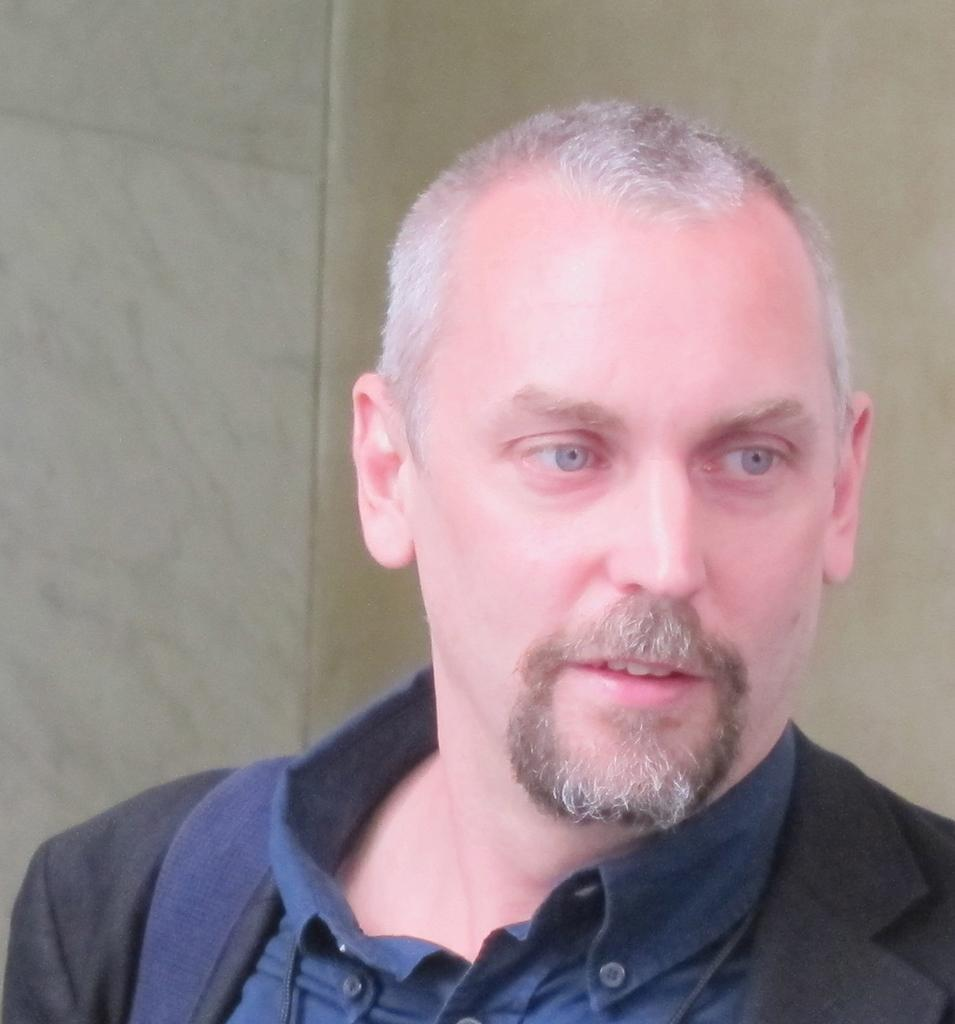Who or what is the main subject of the image? There is a person in the image. What is the person wearing? The person is wearing a black and blue dress. What colors are predominant in the background of the image? The background of the image is white and cream colored. What type of tank can be seen in the background of the image? There is no tank present in the image; the background is white and cream colored. 